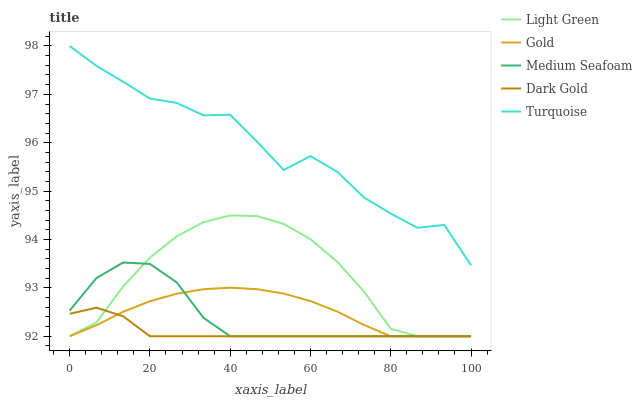Does Dark Gold have the minimum area under the curve?
Answer yes or no. Yes. Does Turquoise have the maximum area under the curve?
Answer yes or no. Yes. Does Gold have the minimum area under the curve?
Answer yes or no. No. Does Gold have the maximum area under the curve?
Answer yes or no. No. Is Gold the smoothest?
Answer yes or no. Yes. Is Turquoise the roughest?
Answer yes or no. Yes. Is Dark Gold the smoothest?
Answer yes or no. No. Is Dark Gold the roughest?
Answer yes or no. No. Does Dark Gold have the lowest value?
Answer yes or no. Yes. Does Turquoise have the highest value?
Answer yes or no. Yes. Does Gold have the highest value?
Answer yes or no. No. Is Medium Seafoam less than Turquoise?
Answer yes or no. Yes. Is Turquoise greater than Light Green?
Answer yes or no. Yes. Does Light Green intersect Medium Seafoam?
Answer yes or no. Yes. Is Light Green less than Medium Seafoam?
Answer yes or no. No. Is Light Green greater than Medium Seafoam?
Answer yes or no. No. Does Medium Seafoam intersect Turquoise?
Answer yes or no. No. 